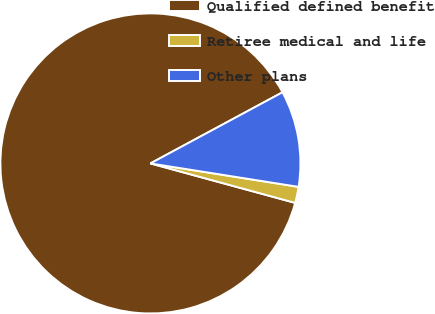Convert chart. <chart><loc_0><loc_0><loc_500><loc_500><pie_chart><fcel>Qualified defined benefit<fcel>Retiree medical and life<fcel>Other plans<nl><fcel>87.9%<fcel>1.74%<fcel>10.36%<nl></chart> 